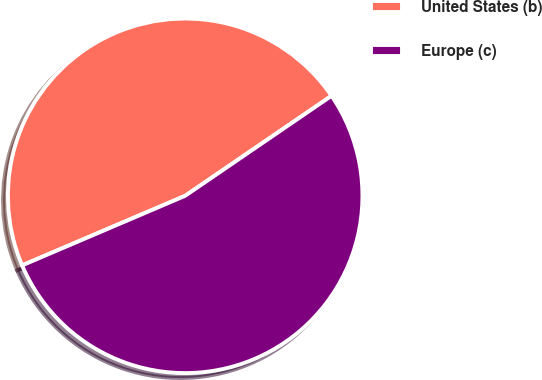Convert chart. <chart><loc_0><loc_0><loc_500><loc_500><pie_chart><fcel>United States (b)<fcel>Europe (c)<nl><fcel>46.88%<fcel>53.12%<nl></chart> 